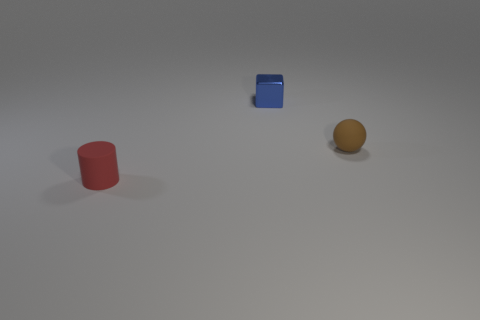Add 3 matte spheres. How many objects exist? 6 Subtract all cylinders. How many objects are left? 2 Subtract all small blue blocks. Subtract all red matte balls. How many objects are left? 2 Add 2 small red rubber cylinders. How many small red rubber cylinders are left? 3 Add 3 large green metal objects. How many large green metal objects exist? 3 Subtract 0 cyan cubes. How many objects are left? 3 